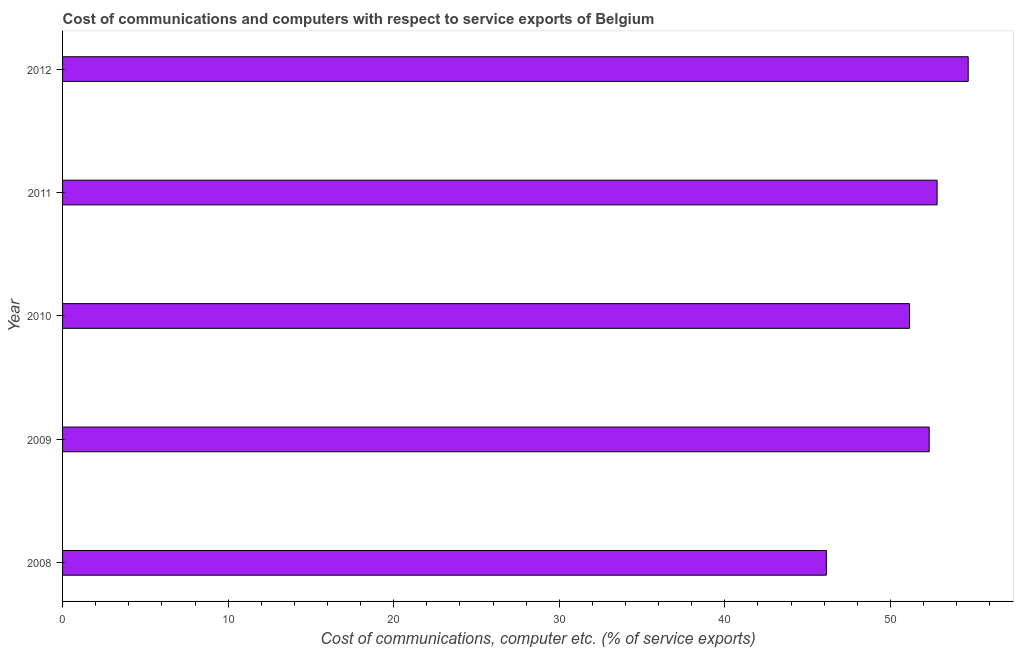Does the graph contain any zero values?
Give a very brief answer. No. Does the graph contain grids?
Provide a succinct answer. No. What is the title of the graph?
Make the answer very short. Cost of communications and computers with respect to service exports of Belgium. What is the label or title of the X-axis?
Keep it short and to the point. Cost of communications, computer etc. (% of service exports). What is the label or title of the Y-axis?
Make the answer very short. Year. What is the cost of communications and computer in 2011?
Give a very brief answer. 52.82. Across all years, what is the maximum cost of communications and computer?
Your answer should be compact. 54.7. Across all years, what is the minimum cost of communications and computer?
Make the answer very short. 46.13. What is the sum of the cost of communications and computer?
Provide a succinct answer. 257.14. What is the difference between the cost of communications and computer in 2010 and 2011?
Provide a succinct answer. -1.66. What is the average cost of communications and computer per year?
Give a very brief answer. 51.43. What is the median cost of communications and computer?
Provide a succinct answer. 52.34. What is the ratio of the cost of communications and computer in 2008 to that in 2011?
Offer a terse response. 0.87. Is the cost of communications and computer in 2008 less than that in 2010?
Your answer should be very brief. Yes. Is the difference between the cost of communications and computer in 2011 and 2012 greater than the difference between any two years?
Ensure brevity in your answer.  No. What is the difference between the highest and the second highest cost of communications and computer?
Give a very brief answer. 1.88. What is the difference between the highest and the lowest cost of communications and computer?
Offer a very short reply. 8.57. Are all the bars in the graph horizontal?
Your answer should be compact. Yes. Are the values on the major ticks of X-axis written in scientific E-notation?
Offer a terse response. No. What is the Cost of communications, computer etc. (% of service exports) in 2008?
Offer a very short reply. 46.13. What is the Cost of communications, computer etc. (% of service exports) of 2009?
Provide a short and direct response. 52.34. What is the Cost of communications, computer etc. (% of service exports) in 2010?
Make the answer very short. 51.16. What is the Cost of communications, computer etc. (% of service exports) in 2011?
Keep it short and to the point. 52.82. What is the Cost of communications, computer etc. (% of service exports) of 2012?
Give a very brief answer. 54.7. What is the difference between the Cost of communications, computer etc. (% of service exports) in 2008 and 2009?
Your response must be concise. -6.21. What is the difference between the Cost of communications, computer etc. (% of service exports) in 2008 and 2010?
Offer a terse response. -5.03. What is the difference between the Cost of communications, computer etc. (% of service exports) in 2008 and 2011?
Your response must be concise. -6.69. What is the difference between the Cost of communications, computer etc. (% of service exports) in 2008 and 2012?
Provide a succinct answer. -8.57. What is the difference between the Cost of communications, computer etc. (% of service exports) in 2009 and 2010?
Your answer should be very brief. 1.19. What is the difference between the Cost of communications, computer etc. (% of service exports) in 2009 and 2011?
Keep it short and to the point. -0.48. What is the difference between the Cost of communications, computer etc. (% of service exports) in 2009 and 2012?
Offer a terse response. -2.36. What is the difference between the Cost of communications, computer etc. (% of service exports) in 2010 and 2011?
Make the answer very short. -1.66. What is the difference between the Cost of communications, computer etc. (% of service exports) in 2010 and 2012?
Provide a succinct answer. -3.54. What is the difference between the Cost of communications, computer etc. (% of service exports) in 2011 and 2012?
Provide a short and direct response. -1.88. What is the ratio of the Cost of communications, computer etc. (% of service exports) in 2008 to that in 2009?
Offer a terse response. 0.88. What is the ratio of the Cost of communications, computer etc. (% of service exports) in 2008 to that in 2010?
Your answer should be very brief. 0.9. What is the ratio of the Cost of communications, computer etc. (% of service exports) in 2008 to that in 2011?
Ensure brevity in your answer.  0.87. What is the ratio of the Cost of communications, computer etc. (% of service exports) in 2008 to that in 2012?
Offer a very short reply. 0.84. What is the ratio of the Cost of communications, computer etc. (% of service exports) in 2009 to that in 2010?
Make the answer very short. 1.02. What is the ratio of the Cost of communications, computer etc. (% of service exports) in 2010 to that in 2012?
Provide a succinct answer. 0.94. 